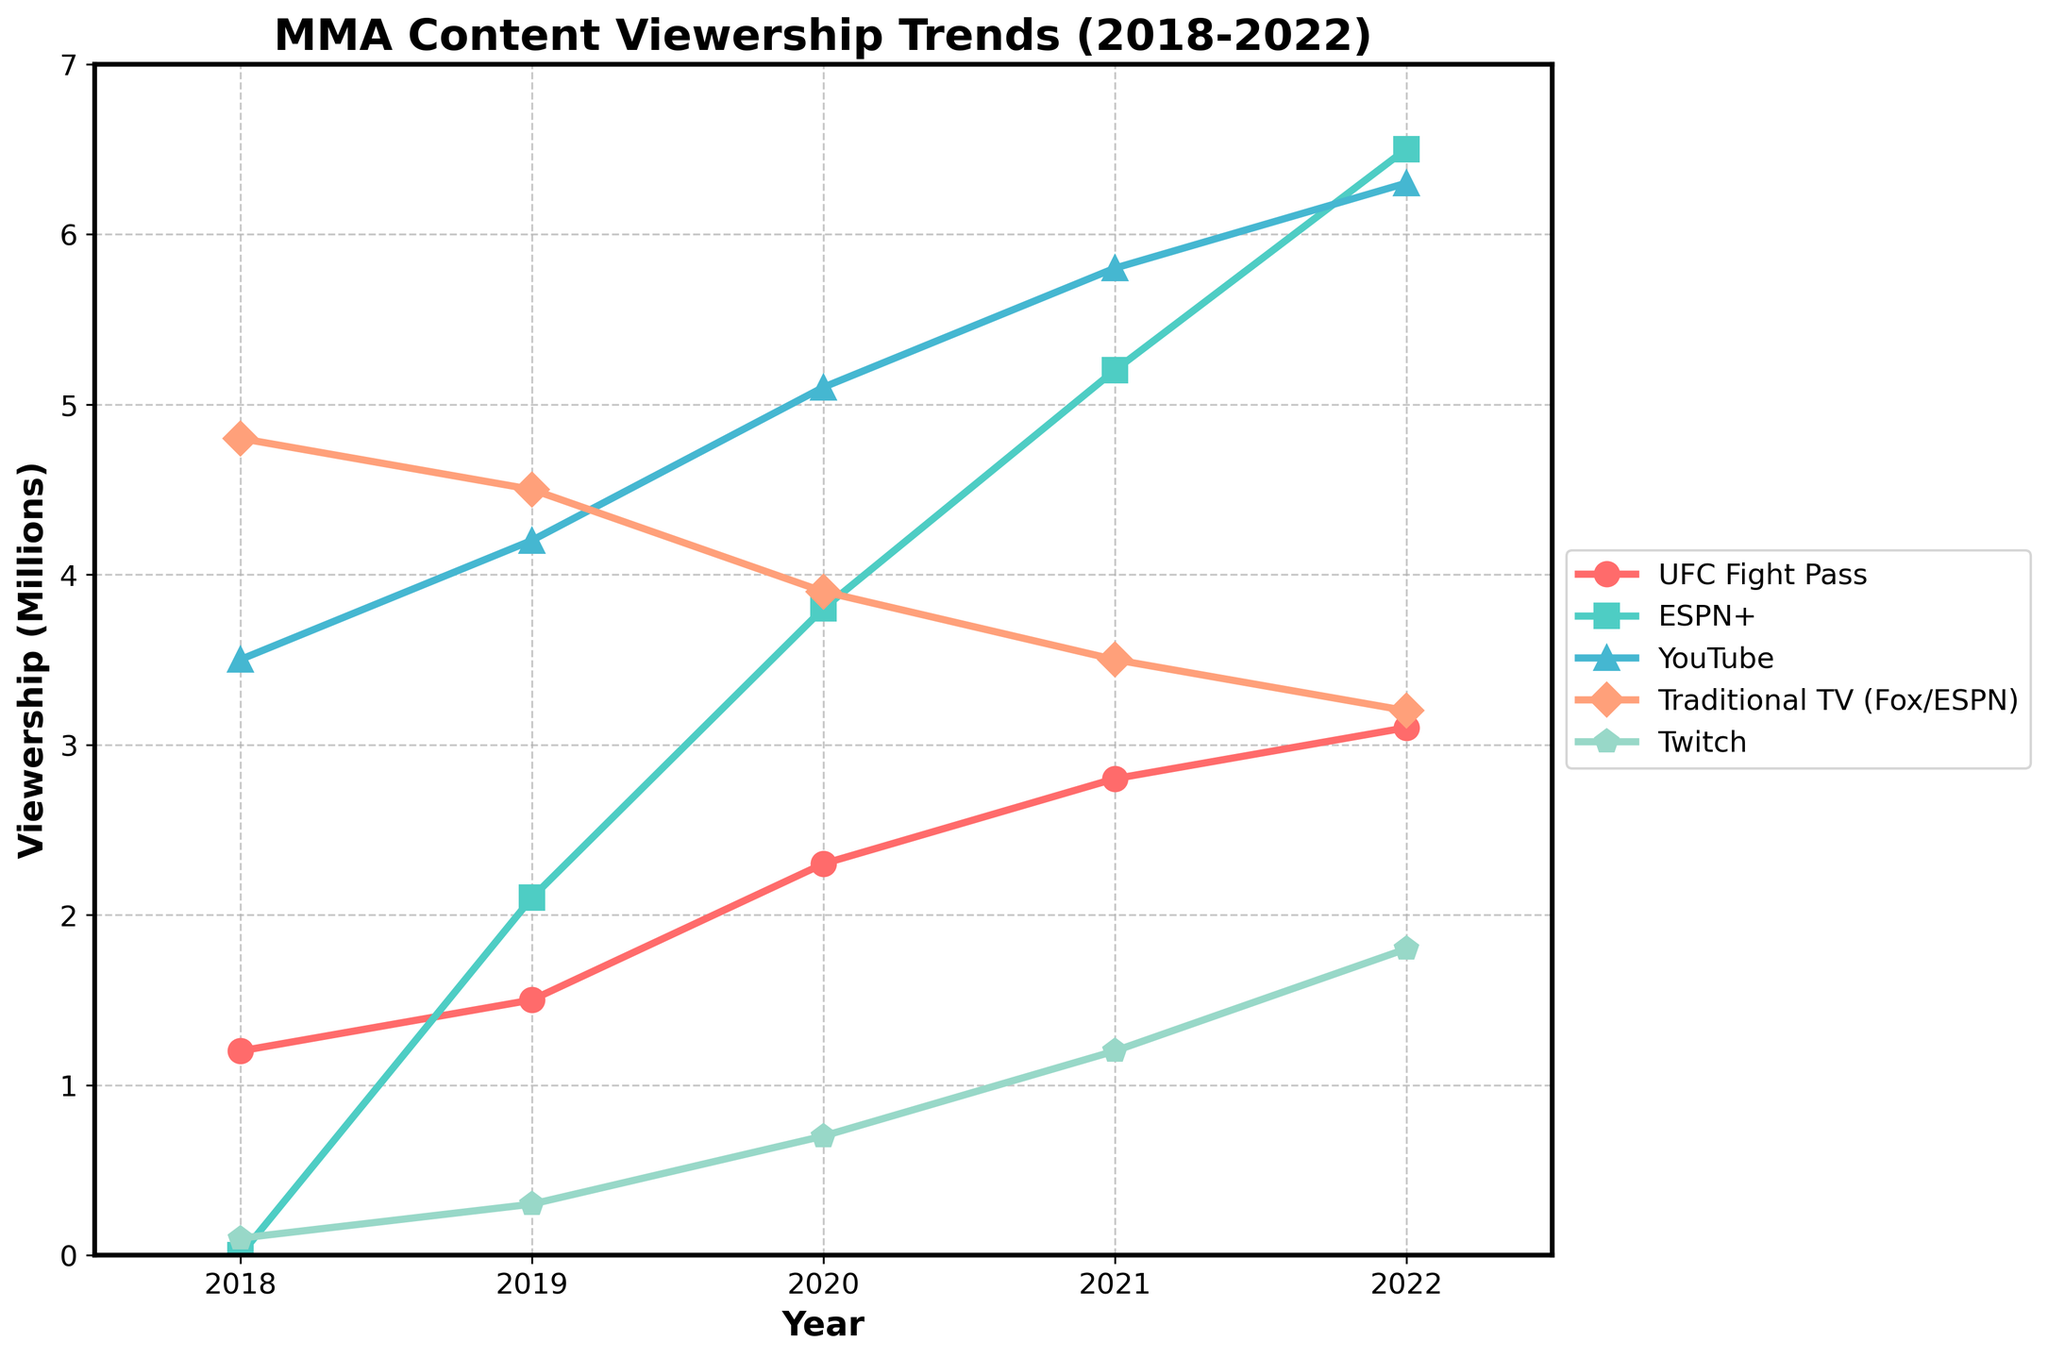Which platform saw the greatest increase in viewership from 2018 to 2022? To find the greatest increase, subtract the 2018 viewership from the 2022 viewership for each platform. ESPN+ increased from 0 to 6.5 million, UFC Fight Pass increased from 1.2 to 3.1 million, YouTube increased from 3.5 to 6.3 million, Traditional TV decreased from 4.8 to 3.2 million, and Twitch increased from 0.1 to 1.8 million. ESPN+ saw the greatest increase.
Answer: ESPN+ In which year did YouTube have its highest viewership? Referring to the figure, compare YouTube viewership across all years. YouTube viewership increased from 3.5 million in 2018 to 6.3 million in 2022, with the highest being in 2022.
Answer: 2022 How does the viewership trend of Traditional TV compare to ESPN+ from 2018 to 2022? Compare the plotted lines for Traditional TV and ESPN+ from 2018 to 2022. Traditional TV's viewership decreased from 4.8 million to 3.2 million, while ESPN+'s viewership increased from 0 to 6.5 million over the same period. This shows an opposite trend: a decline for Traditional TV and a rise for ESPN+.
Answer: Traditional TV declined, ESPN+ increased What is the total increase in viewership for UFC Fight Pass from 2018 to 2022? To find the total increase, subtract the 2018 viewership from the 2022 viewership for UFC Fight Pass: 3.1 million - 1.2 million.
Answer: 1.9 million Which platforms had viewership of more than 5 million in 2021? Check the 2021 viewership for all platforms and note those above 5 million: ESPN+ (5.2 million) and YouTube (5.8 million).
Answer: ESPN+, YouTube What is the average viewership for Twitch from 2019 to 2022? The viewership for Twitch from 2019 to 2022 is 0.3, 0.7, 1.2, and 1.8 million respectively. Summing these (0.3 + 0.7 + 1.2 + 1.8) gives 4. Thus, the average is 4/4 = 1 million.
Answer: 1 million Which year saw the largest difference in viewership between YouTube and Traditional TV? Calculate the difference for each year: 2018 (3.5-4.8), 2019 (4.2-4.5), 2020 (5.1-3.9), 2021 (5.8-3.5), 2022 (6.3-3.2). The largest difference is in 2022: 6.3 - 3.2 = 3.1.
Answer: 2022 Did any platform's viewership decrease from one year to the next within the five-year span? Check the viewership for all platforms year-by-year; Traditional TV had a decrease from 4.8 million in 2018 to 4.5 million in 2019, then to 3.9 million in 2020, to 3.5 million in 2021, and to 3.2 million in 2022. No other platform shows a year-to-year decrease.
Answer: Yes, Traditional TV If you sum the viewership of all platforms in 2020, what is the total? Add the viewership for each platform in 2020: UFC Fight Pass (2.3), ESPN+ (3.8), YouTube (5.1), Traditional TV (3.9), and Twitch (0.7). So, 2.3 + 3.8 + 5.1 + 3.9 + 0.7 = 15.8 million.
Answer: 15.8 million 